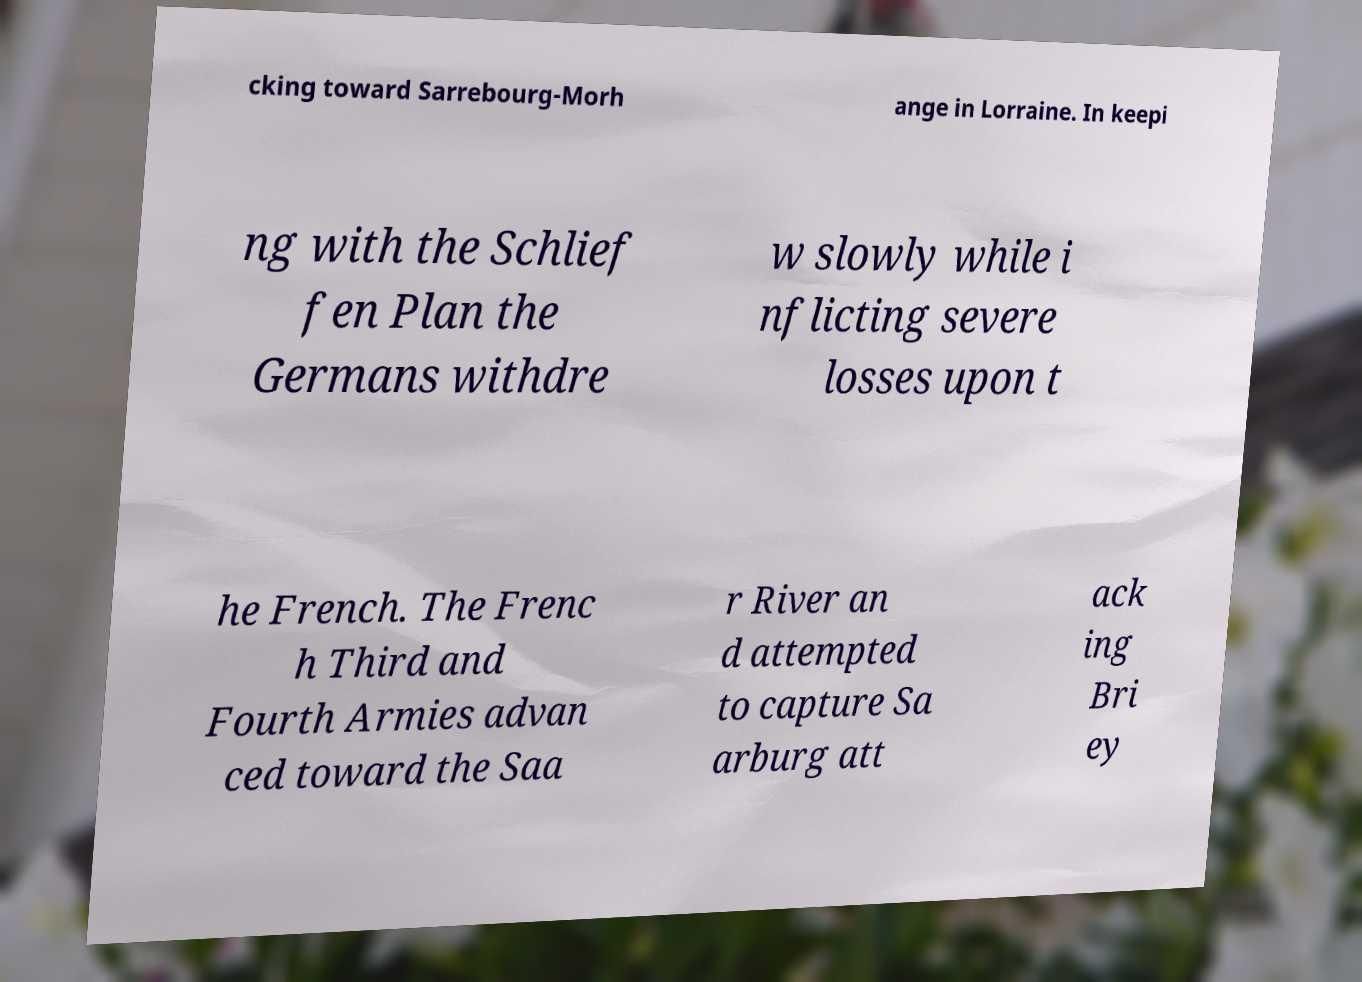Can you accurately transcribe the text from the provided image for me? cking toward Sarrebourg-Morh ange in Lorraine. In keepi ng with the Schlief fen Plan the Germans withdre w slowly while i nflicting severe losses upon t he French. The Frenc h Third and Fourth Armies advan ced toward the Saa r River an d attempted to capture Sa arburg att ack ing Bri ey 